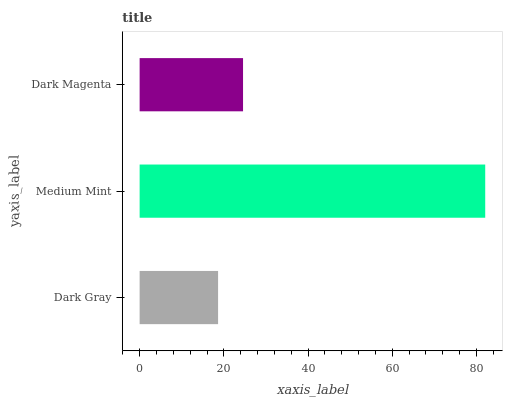Is Dark Gray the minimum?
Answer yes or no. Yes. Is Medium Mint the maximum?
Answer yes or no. Yes. Is Dark Magenta the minimum?
Answer yes or no. No. Is Dark Magenta the maximum?
Answer yes or no. No. Is Medium Mint greater than Dark Magenta?
Answer yes or no. Yes. Is Dark Magenta less than Medium Mint?
Answer yes or no. Yes. Is Dark Magenta greater than Medium Mint?
Answer yes or no. No. Is Medium Mint less than Dark Magenta?
Answer yes or no. No. Is Dark Magenta the high median?
Answer yes or no. Yes. Is Dark Magenta the low median?
Answer yes or no. Yes. Is Medium Mint the high median?
Answer yes or no. No. Is Medium Mint the low median?
Answer yes or no. No. 